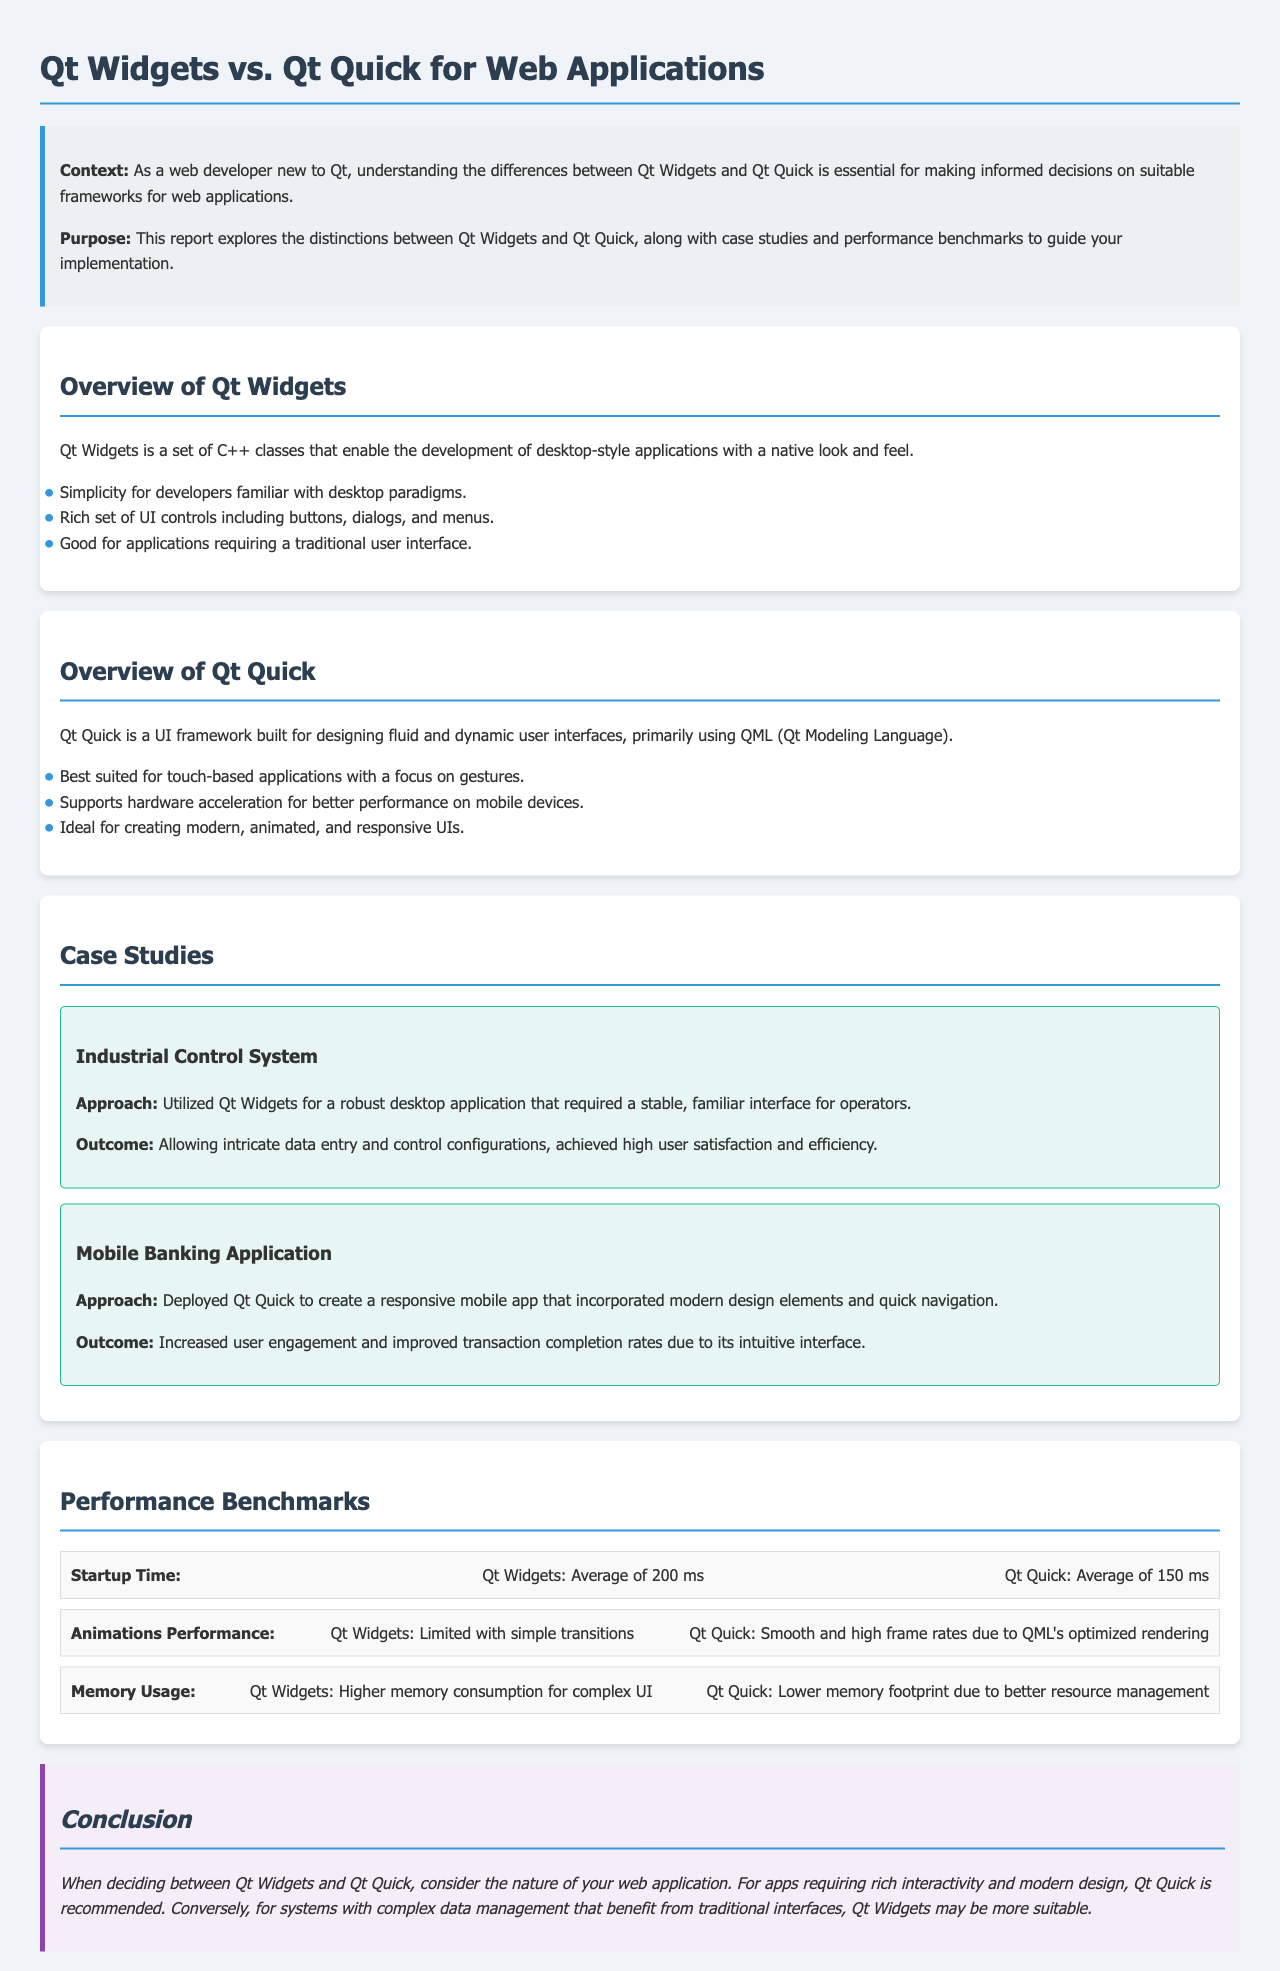What is the primary purpose of the report? The report aims to explore the distinctions between Qt Widgets and Qt Quick, providing guidance on implementation.
Answer: Explore distinctions between Qt Widgets and Qt Quick What UI framework is best for touch-based applications? Qt Quick is specifically mentioned as best suited for touch-based applications focusing on gestures.
Answer: Qt Quick What is the application type discussed in the Industrial Control System case study? The case study highlights a robust desktop application requiring a stable interface for operators.
Answer: Desktop application What is the average startup time for Qt Quick? The document states that the average startup time for Qt Quick is 150 ms.
Answer: 150 ms How does Qt Widgets compare to Qt Quick in terms of animations performance? The document notes Qt Widgets has limited animations performance compared to the smooth, high frame rates of Qt Quick.
Answer: Limited with simple transitions What type of application did the Mobile Banking Application case study focus on? The case study refers to a mobile app focusing on modern design elements and quick navigation.
Answer: Mobile app What is the memory usage comparison between Qt Widgets and Qt Quick? The document indicates that Qt Widgets has higher memory consumption while Qt Quick has a lower memory footprint.
Answer: Higher memory consumption What is emphasized as important when choosing between Qt Widgets and Qt Quick? The report emphasizes considering the nature of the web application when making the choice.
Answer: Nature of your web application What color is used for the report's section headers? The headers are styled with a color that matches the report's overall design, specifically a dark blue tone.
Answer: Dark blue 